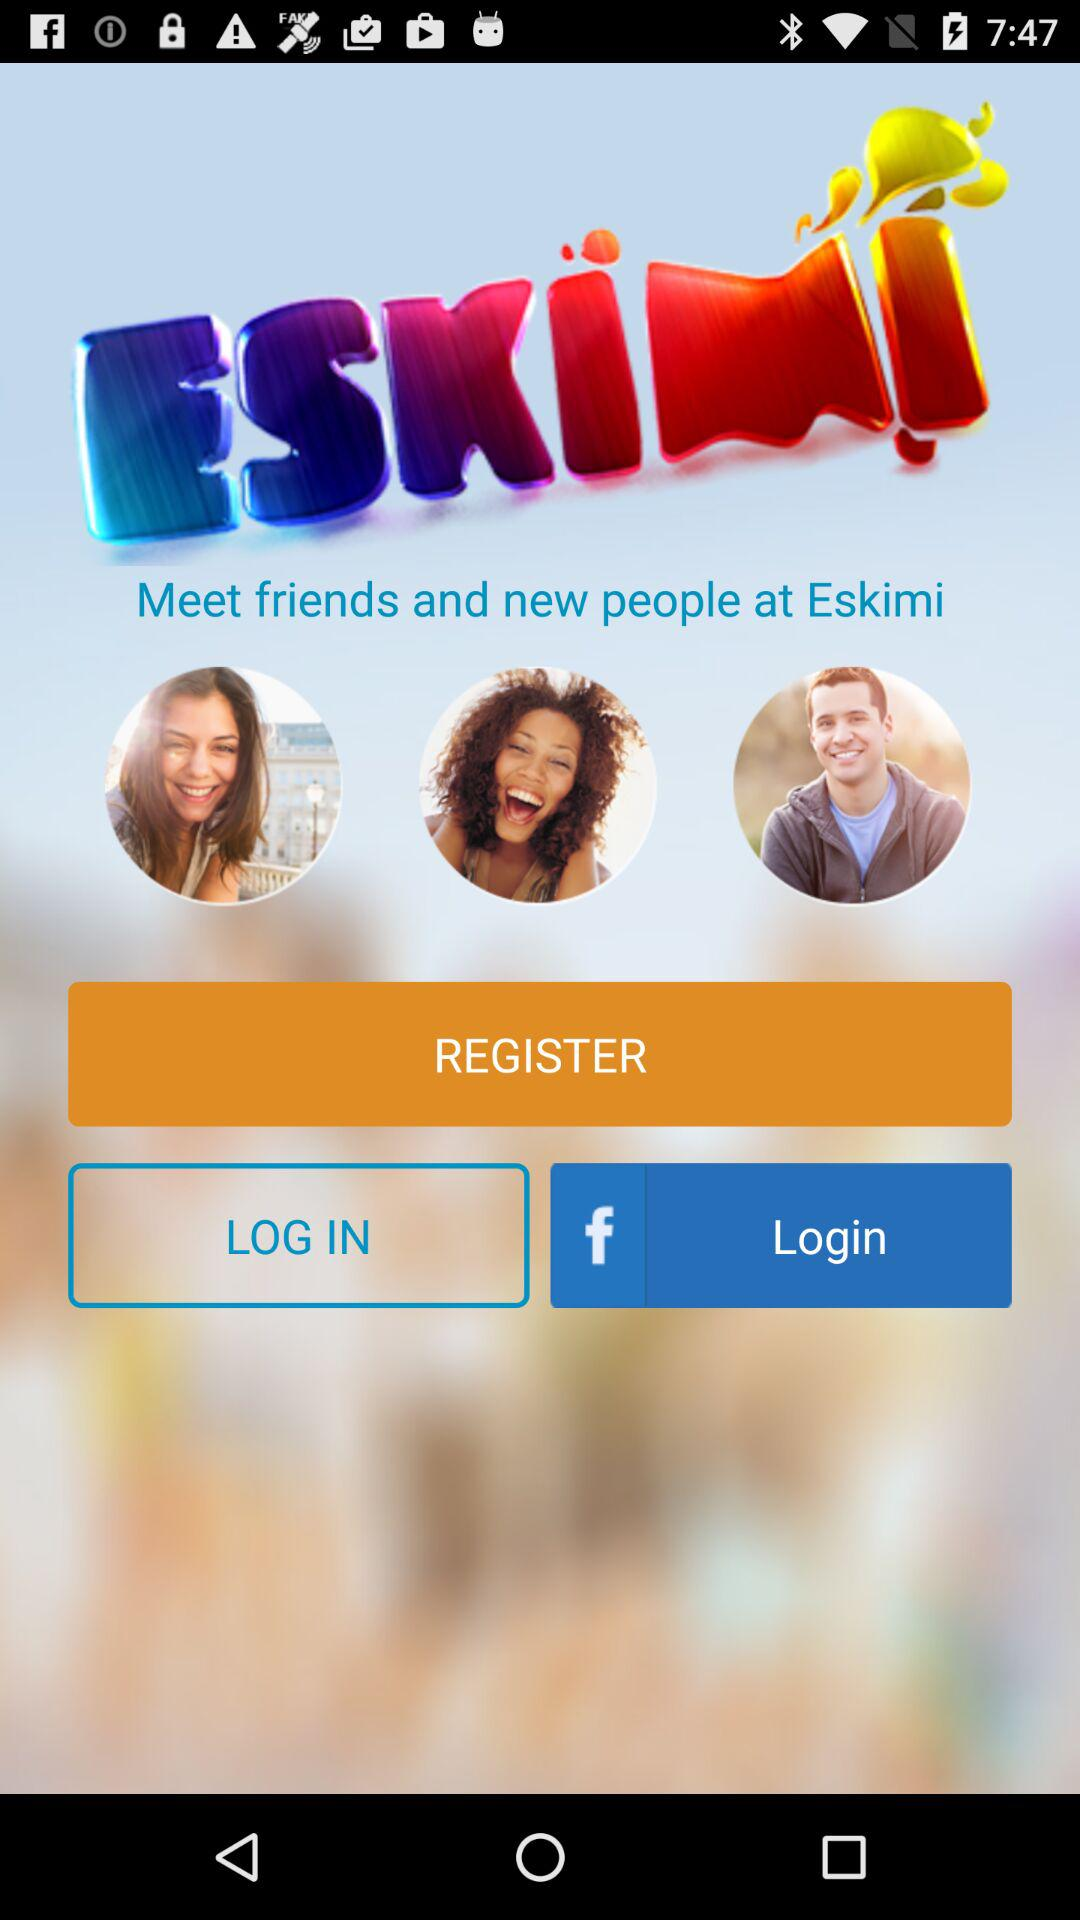Through what application can I log in? You can login through "Facebook". 